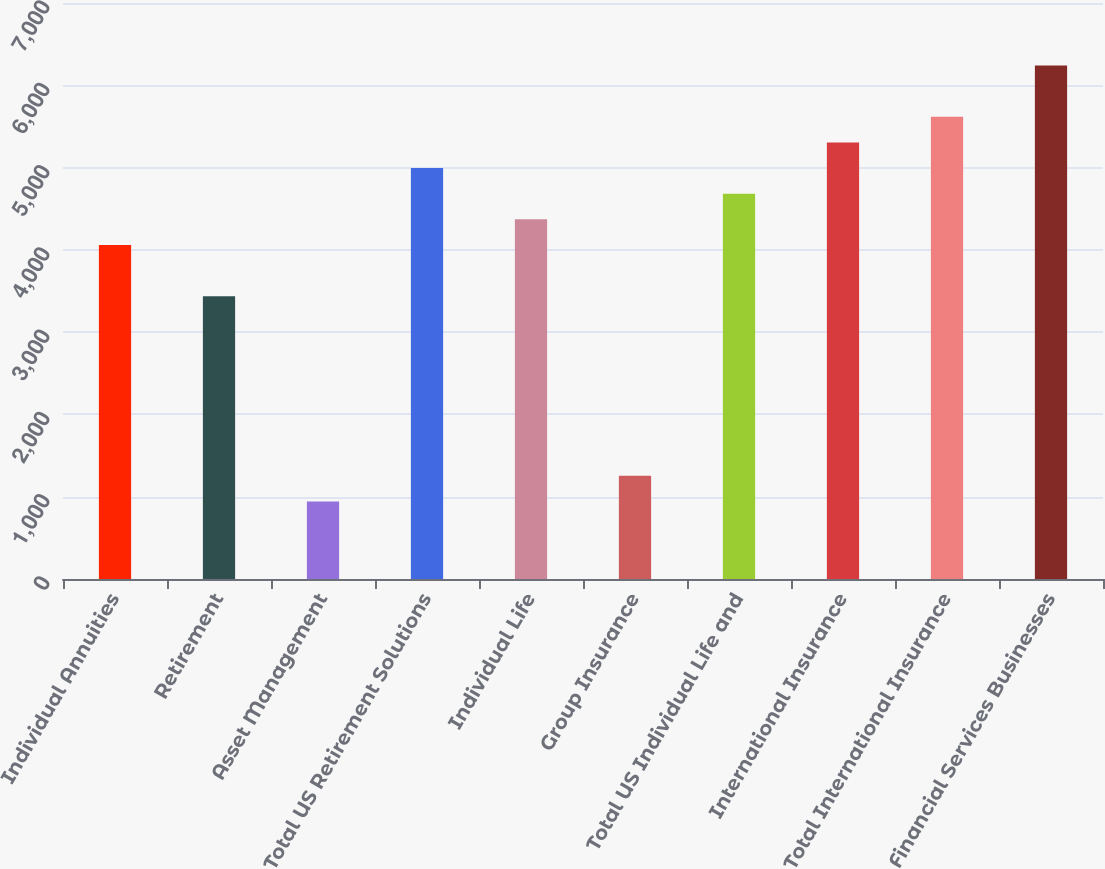<chart> <loc_0><loc_0><loc_500><loc_500><bar_chart><fcel>Individual Annuities<fcel>Retirement<fcel>Asset Management<fcel>Total US Retirement Solutions<fcel>Individual Life<fcel>Group Insurance<fcel>Total US Individual Life and<fcel>International Insurance<fcel>Total International Insurance<fcel>Financial Services Businesses<nl><fcel>4058.91<fcel>3435.63<fcel>942.51<fcel>4993.83<fcel>4370.55<fcel>1254.15<fcel>4682.19<fcel>5305.47<fcel>5617.11<fcel>6240.39<nl></chart> 